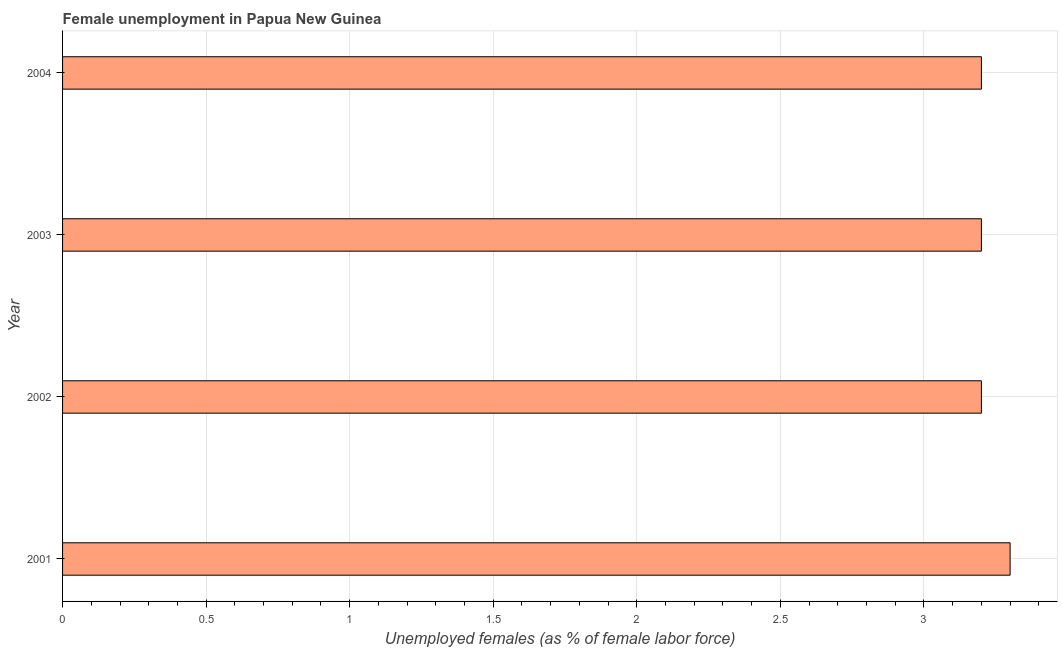What is the title of the graph?
Give a very brief answer. Female unemployment in Papua New Guinea. What is the label or title of the X-axis?
Provide a succinct answer. Unemployed females (as % of female labor force). What is the unemployed females population in 2002?
Keep it short and to the point. 3.2. Across all years, what is the maximum unemployed females population?
Provide a short and direct response. 3.3. Across all years, what is the minimum unemployed females population?
Ensure brevity in your answer.  3.2. In which year was the unemployed females population minimum?
Your answer should be very brief. 2002. What is the sum of the unemployed females population?
Provide a short and direct response. 12.9. What is the difference between the unemployed females population in 2001 and 2003?
Make the answer very short. 0.1. What is the average unemployed females population per year?
Your response must be concise. 3.23. What is the median unemployed females population?
Make the answer very short. 3.2. In how many years, is the unemployed females population greater than 2.6 %?
Your answer should be very brief. 4. Do a majority of the years between 2002 and 2004 (inclusive) have unemployed females population greater than 1.7 %?
Provide a short and direct response. Yes. What is the difference between the highest and the second highest unemployed females population?
Ensure brevity in your answer.  0.1. What is the difference between the highest and the lowest unemployed females population?
Provide a short and direct response. 0.1. How many years are there in the graph?
Your answer should be compact. 4. What is the Unemployed females (as % of female labor force) of 2001?
Provide a succinct answer. 3.3. What is the Unemployed females (as % of female labor force) in 2002?
Give a very brief answer. 3.2. What is the Unemployed females (as % of female labor force) of 2003?
Offer a terse response. 3.2. What is the Unemployed females (as % of female labor force) in 2004?
Provide a short and direct response. 3.2. What is the difference between the Unemployed females (as % of female labor force) in 2001 and 2002?
Your answer should be very brief. 0.1. What is the difference between the Unemployed females (as % of female labor force) in 2001 and 2004?
Offer a terse response. 0.1. What is the difference between the Unemployed females (as % of female labor force) in 2003 and 2004?
Offer a terse response. 0. What is the ratio of the Unemployed females (as % of female labor force) in 2001 to that in 2002?
Offer a terse response. 1.03. What is the ratio of the Unemployed females (as % of female labor force) in 2001 to that in 2003?
Your answer should be very brief. 1.03. What is the ratio of the Unemployed females (as % of female labor force) in 2001 to that in 2004?
Make the answer very short. 1.03. 